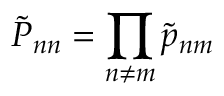<formula> <loc_0><loc_0><loc_500><loc_500>{ \tilde { P } } _ { n n } = \prod _ { n \neq m } \tilde { p } _ { n m }</formula> 